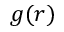Convert formula to latex. <formula><loc_0><loc_0><loc_500><loc_500>g ( r )</formula> 